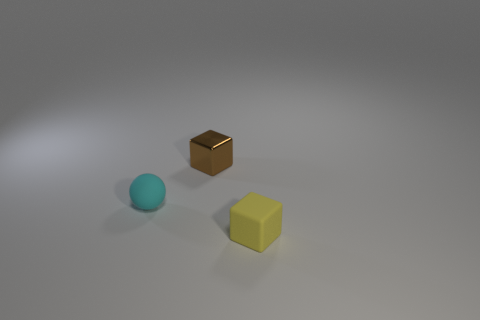Are there any shiny things that have the same size as the yellow matte block?
Make the answer very short. Yes. Is the number of tiny brown cubes that are to the right of the tiny brown object less than the number of brown blocks?
Offer a very short reply. Yes. There is a tiny thing on the left side of the block that is behind the small rubber object that is in front of the small rubber sphere; what is it made of?
Offer a terse response. Rubber. Are there more matte balls that are behind the small matte sphere than small yellow objects that are in front of the rubber cube?
Your answer should be very brief. No. What number of metallic things are either cyan objects or brown objects?
Keep it short and to the point. 1. What is the material of the small object that is behind the small cyan matte thing?
Your answer should be very brief. Metal. What number of things are either small purple shiny objects or small things on the left side of the small brown metallic thing?
Your answer should be compact. 1. What is the shape of the metallic object that is the same size as the yellow matte block?
Your answer should be very brief. Cube. Is the material of the cube behind the cyan sphere the same as the small cyan ball?
Offer a very short reply. No. The brown metallic thing has what shape?
Provide a short and direct response. Cube. 